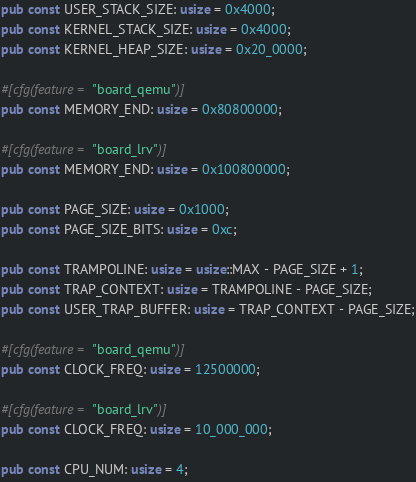<code> <loc_0><loc_0><loc_500><loc_500><_Rust_>pub const USER_STACK_SIZE: usize = 0x4000;
pub const KERNEL_STACK_SIZE: usize = 0x4000;
pub const KERNEL_HEAP_SIZE: usize = 0x20_0000;

#[cfg(feature = "board_qemu")]
pub const MEMORY_END: usize = 0x80800000;

#[cfg(feature = "board_lrv")]
pub const MEMORY_END: usize = 0x100800000;

pub const PAGE_SIZE: usize = 0x1000;
pub const PAGE_SIZE_BITS: usize = 0xc;

pub const TRAMPOLINE: usize = usize::MAX - PAGE_SIZE + 1;
pub const TRAP_CONTEXT: usize = TRAMPOLINE - PAGE_SIZE;
pub const USER_TRAP_BUFFER: usize = TRAP_CONTEXT - PAGE_SIZE;

#[cfg(feature = "board_qemu")]
pub const CLOCK_FREQ: usize = 12500000;

#[cfg(feature = "board_lrv")]
pub const CLOCK_FREQ: usize = 10_000_000;

pub const CPU_NUM: usize = 4;
</code> 